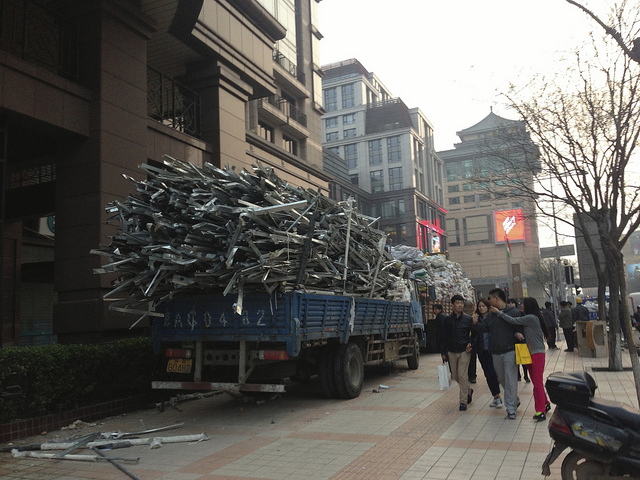<image>What street is this taking place? It's ambiguous which street this is taking place on. It could be Broad, Main, 6th Ave, Main St, or Broadway. What street is this taking place? It is unknown what street this is taking place on. However, it can be seen that it might be on '6th ave', 'main st', or 'broadway'. 